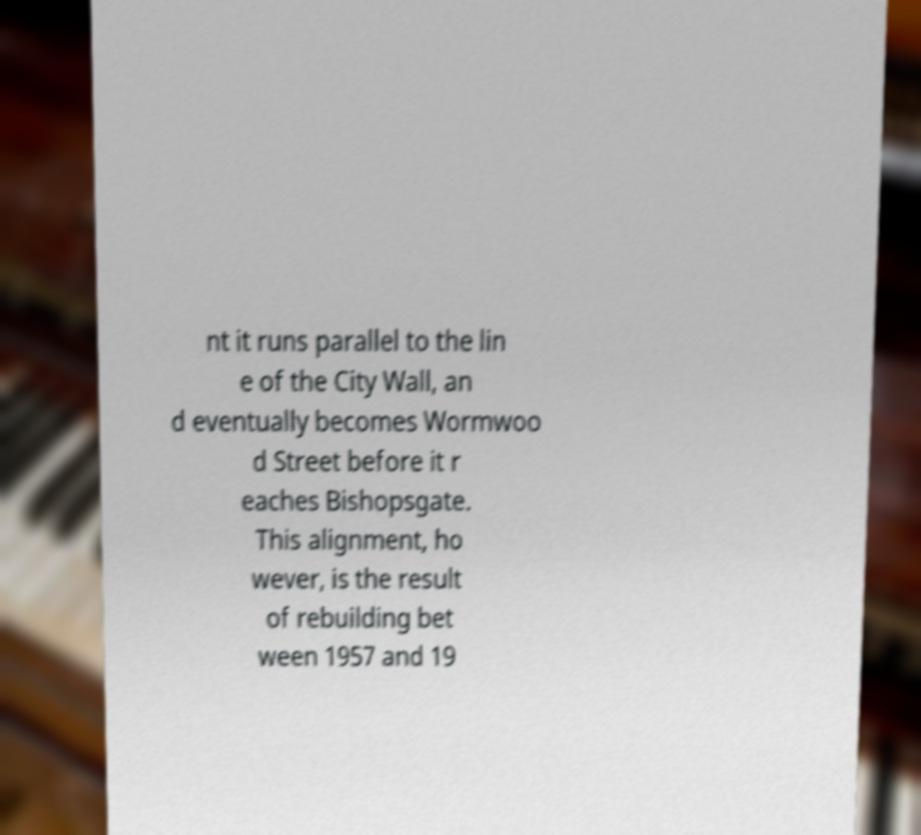Could you assist in decoding the text presented in this image and type it out clearly? nt it runs parallel to the lin e of the City Wall, an d eventually becomes Wormwoo d Street before it r eaches Bishopsgate. This alignment, ho wever, is the result of rebuilding bet ween 1957 and 19 